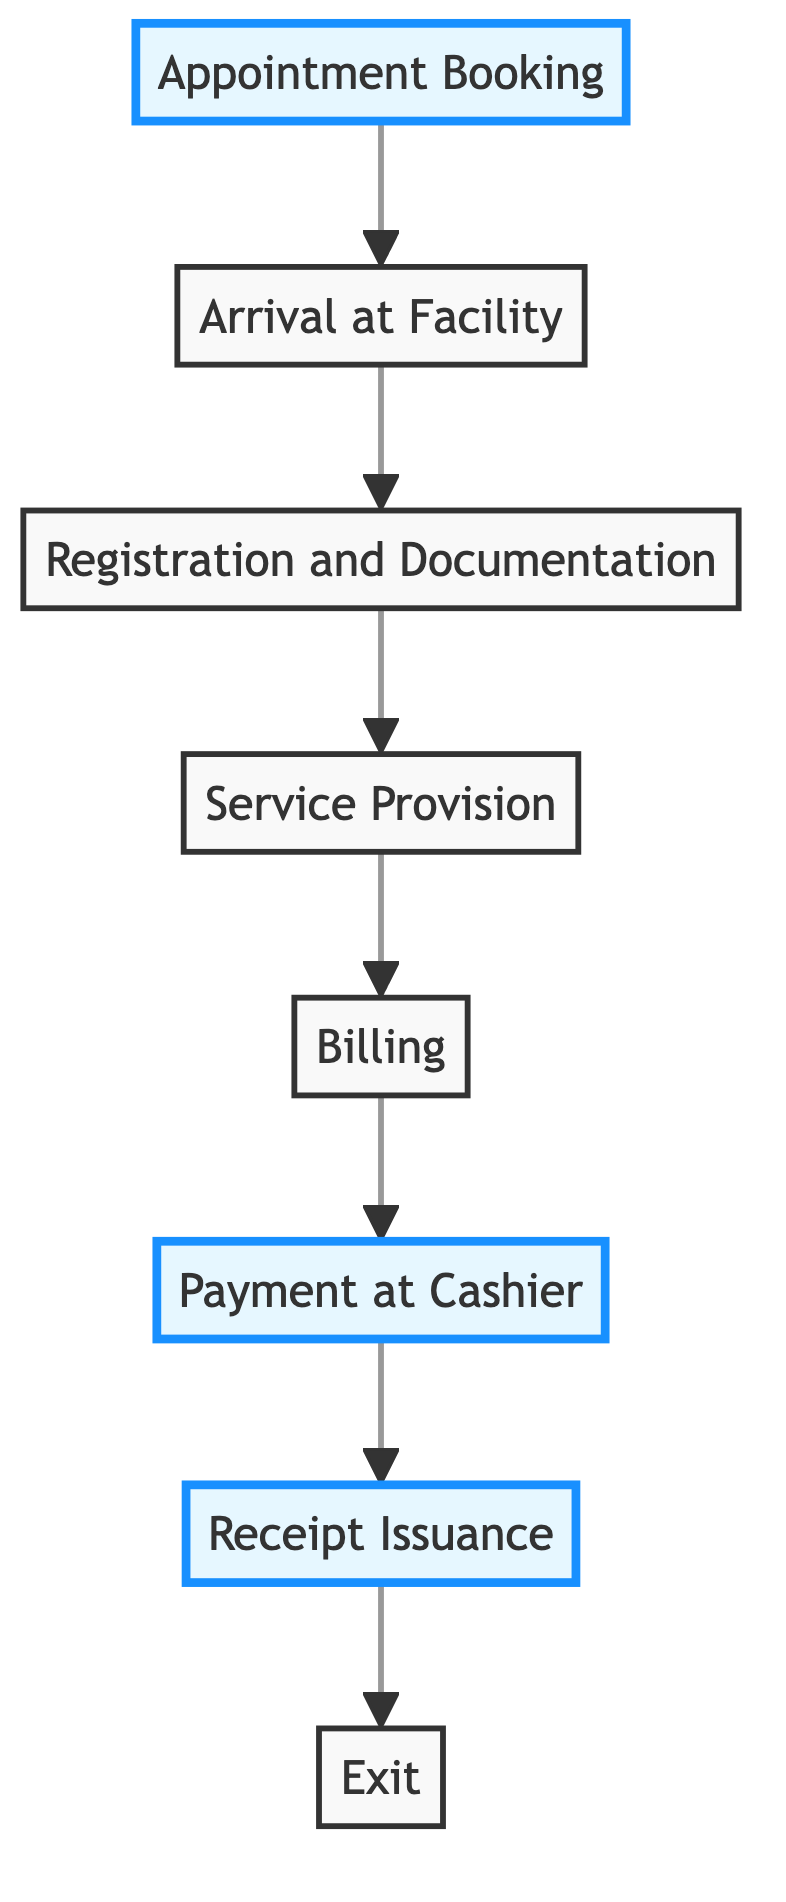What is the first step in the payment process? The first step in the diagram identifies "Appointment Booking" as the beginning of the patient journey in the payment process, demonstrating that booking an appointment is necessary before arriving at the facility.
Answer: Appointment Booking How many steps are there in the payment process? By counting the nodes depicted in the diagram, we find a total of eight steps, from "Appointment Booking" through to "Exit."
Answer: Eight What happens after "Service Provision"? According to the flow of the diagram, "Billing" comes directly after "Service Provision," indicating that once the medical services are provided, the next action is to prepare the patient's invoice.
Answer: Billing What is the last step in the patient journey? The diagram indicates that the patient journey concludes with the "Exit" step, which represents the final action where the patient leaves the medical facility.
Answer: Exit Which step involves cash payment? The diagram specifies "Payment at Cashier" as the step where the patient makes the cash payment for services received in the medical facility.
Answer: Payment at Cashier What two steps are highlighted in the diagram? The highlighted steps in the diagram are "Appointment Booking" and "Receipt Issuance," emphasizing these critical points in the patient journey related to booking appointments and confirming payments.
Answer: Appointment Booking, Receipt Issuance In what order do the steps proceed from billing to exit? The sequence indicated by the diagram shows that after "Billing," the next step is "Payment at Cashier," followed by "Receipt Issuance," and finally "Exit," outlining the flow of the payment process.
Answer: Payment at Cashier, Receipt Issuance, Exit Which step precedes "Registration and Documentation"? The diagram shows that "Arrival at Facility" comes right before "Registration and Documentation," marking the patient's arrival before they provide their information.
Answer: Arrival at Facility 